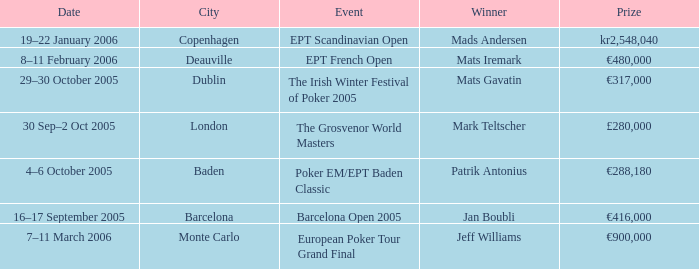When was the event in the City of Baden? 4–6 October 2005. 